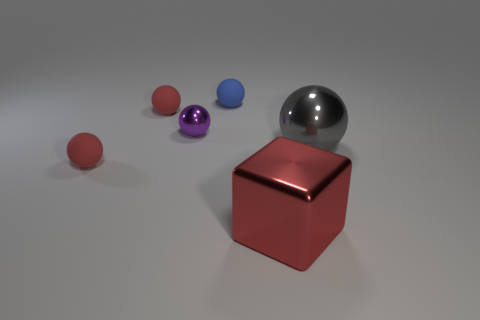Subtract all cyan cubes. Subtract all purple cylinders. How many cubes are left? 1 Subtract all green cubes. How many cyan balls are left? 0 Add 1 small greens. How many grays exist? 0 Subtract all gray shiny things. Subtract all tiny rubber spheres. How many objects are left? 2 Add 5 small red rubber balls. How many small red rubber balls are left? 7 Add 2 big brown rubber balls. How many big brown rubber balls exist? 2 Add 1 blue matte things. How many objects exist? 7 Subtract all purple balls. How many balls are left? 4 Subtract all large gray metal spheres. How many spheres are left? 4 Subtract 0 brown cubes. How many objects are left? 6 